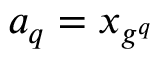<formula> <loc_0><loc_0><loc_500><loc_500>a _ { q } = x _ { g ^ { q } }</formula> 